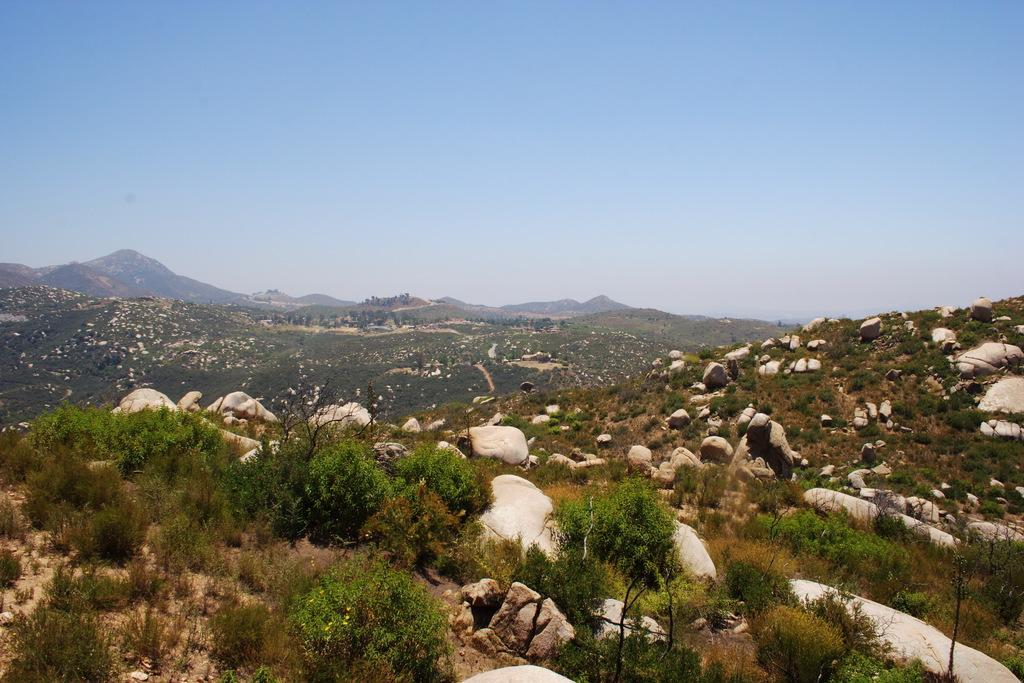What type of natural elements can be seen in the image? There are rocks, trees, and hills visible in the image. What is visible in the background of the image? The sky is visible in the background of the image. What type of linen is used to cover the trees in the image? There is no linen present in the image, and the trees are not covered. 